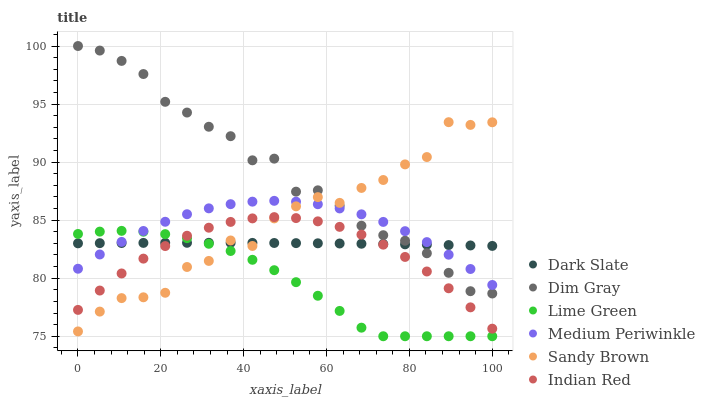Does Lime Green have the minimum area under the curve?
Answer yes or no. Yes. Does Dim Gray have the maximum area under the curve?
Answer yes or no. Yes. Does Sandy Brown have the minimum area under the curve?
Answer yes or no. No. Does Sandy Brown have the maximum area under the curve?
Answer yes or no. No. Is Dark Slate the smoothest?
Answer yes or no. Yes. Is Sandy Brown the roughest?
Answer yes or no. Yes. Is Medium Periwinkle the smoothest?
Answer yes or no. No. Is Medium Periwinkle the roughest?
Answer yes or no. No. Does Lime Green have the lowest value?
Answer yes or no. Yes. Does Sandy Brown have the lowest value?
Answer yes or no. No. Does Dim Gray have the highest value?
Answer yes or no. Yes. Does Sandy Brown have the highest value?
Answer yes or no. No. Is Indian Red less than Medium Periwinkle?
Answer yes or no. Yes. Is Medium Periwinkle greater than Indian Red?
Answer yes or no. Yes. Does Lime Green intersect Sandy Brown?
Answer yes or no. Yes. Is Lime Green less than Sandy Brown?
Answer yes or no. No. Is Lime Green greater than Sandy Brown?
Answer yes or no. No. Does Indian Red intersect Medium Periwinkle?
Answer yes or no. No. 